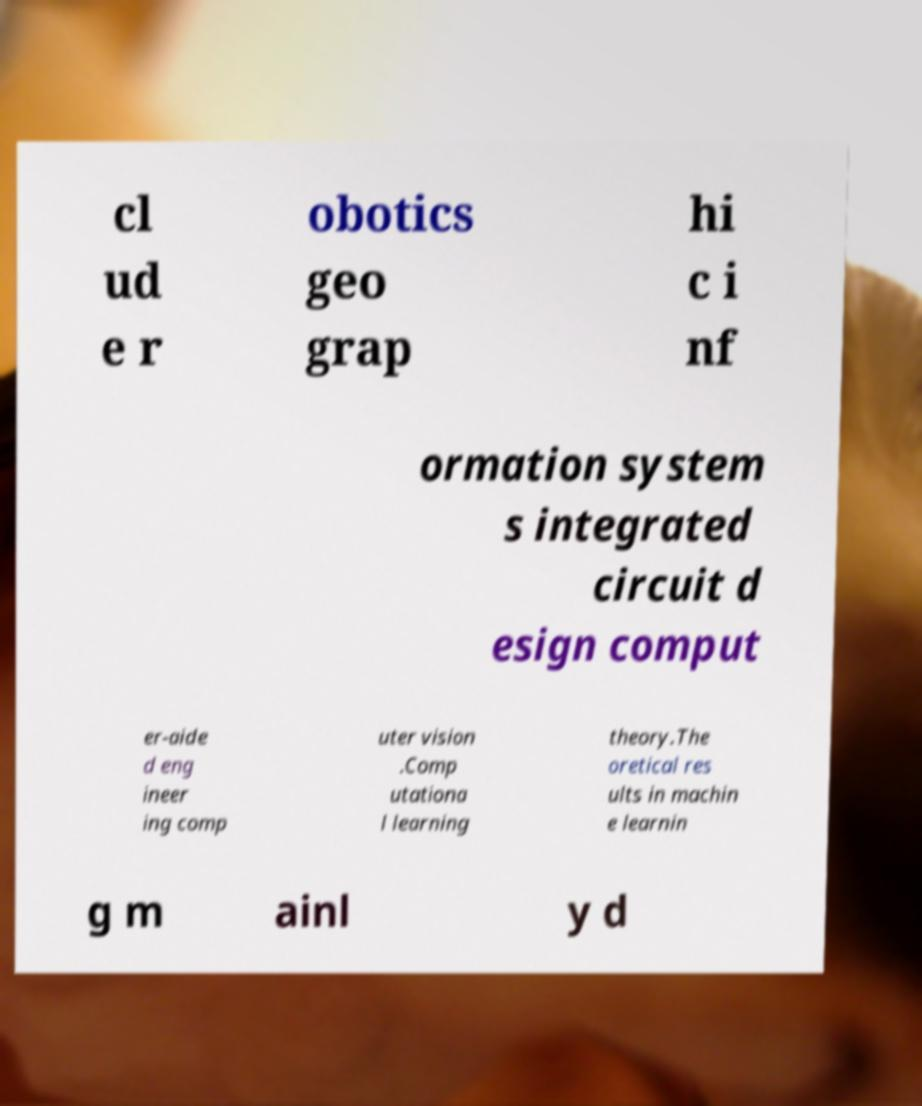What messages or text are displayed in this image? I need them in a readable, typed format. cl ud e r obotics geo grap hi c i nf ormation system s integrated circuit d esign comput er-aide d eng ineer ing comp uter vision .Comp utationa l learning theory.The oretical res ults in machin e learnin g m ainl y d 